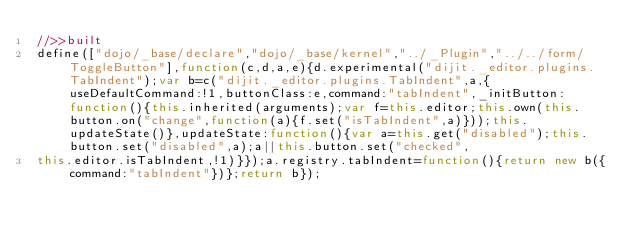Convert code to text. <code><loc_0><loc_0><loc_500><loc_500><_JavaScript_>//>>built
define(["dojo/_base/declare","dojo/_base/kernel","../_Plugin","../../form/ToggleButton"],function(c,d,a,e){d.experimental("dijit._editor.plugins.TabIndent");var b=c("dijit._editor.plugins.TabIndent",a,{useDefaultCommand:!1,buttonClass:e,command:"tabIndent",_initButton:function(){this.inherited(arguments);var f=this.editor;this.own(this.button.on("change",function(a){f.set("isTabIndent",a)}));this.updateState()},updateState:function(){var a=this.get("disabled");this.button.set("disabled",a);a||this.button.set("checked",
this.editor.isTabIndent,!1)}});a.registry.tabIndent=function(){return new b({command:"tabIndent"})};return b});</code> 